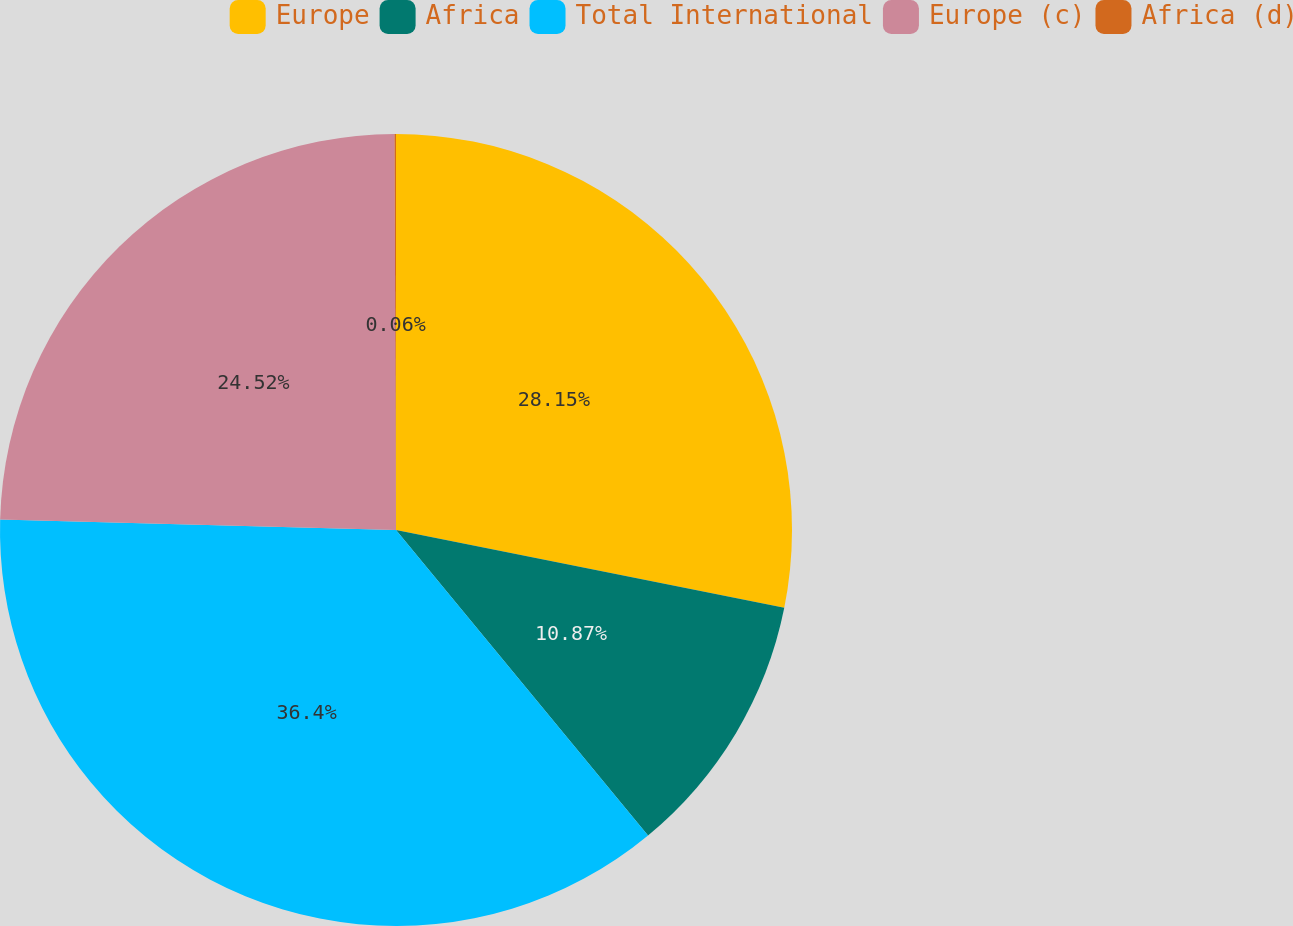Convert chart. <chart><loc_0><loc_0><loc_500><loc_500><pie_chart><fcel>Europe<fcel>Africa<fcel>Total International<fcel>Europe (c)<fcel>Africa (d)<nl><fcel>28.15%<fcel>10.87%<fcel>36.4%<fcel>24.52%<fcel>0.06%<nl></chart> 